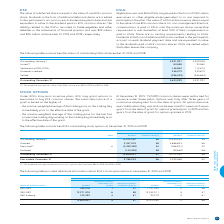According to Bce's financial document, Who can BCE grant options to under BCE's long-term incentive plans? executives to buy BCE common shares. The document states: "ng-term incentive plans, BCE may grant options to executives to buy BCE common shares. The subscription price of a grant is based on the higher of:..." Also, How many common shares were authorized for issuance in 2019? According to the financial document, 7,524,891. The relevant text states: "At December 31, 2019, 7,524,891 common shares were authorized for issuance under these plans. Options vest fully after three years..." Also, Which years have the weighted average market share price for options exercised provided? The document shows two values: 2019 and 2018. From the document: "NUMBER OF DSUs 2019 2018 NUMBER OF DSUs 2019 2018..." Additionally, Which year is the weighted average market share price for options exercised higher? According to the financial document, 2019. The relevant text states: "BCE Inc. 2019 Annual Report 153..." Also, can you calculate: What is the change in granted options in 2019? Based on the calculation: 3,357,303-3,888,693, the result is -531390. This is based on the information: "Granted 3,357,303 58 3,888,693 56 Granted 3,357,303 58 3,888,693 56..." The key data points involved are: 3,357,303, 3,888,693. Also, can you calculate: What is the percentage change in the exercisable number of options in December 31, 2019? To answer this question, I need to perform calculations using the financial data. The calculation is: (2,786,043-4,399,588)/4,399,588, which equals -36.67 (percentage). This is based on the information: "Exercisable, December 31 2,786,043 56 4,399,588 52 Exercisable, December 31 2,786,043 56 4,399,588 52..." The key data points involved are: 2,786,043, 4,399,588. 